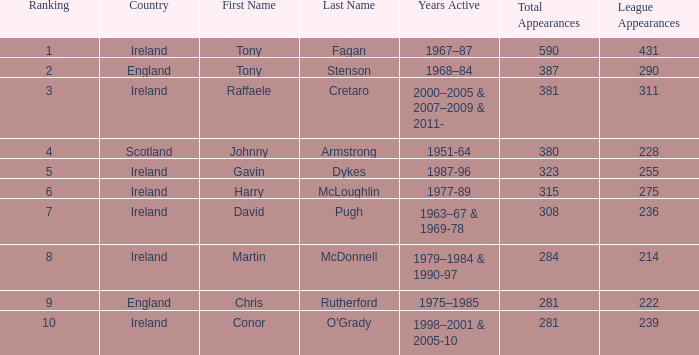How many total appearances (league only) have a name of gavin dykes? 323(255). 